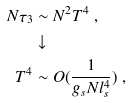Convert formula to latex. <formula><loc_0><loc_0><loc_500><loc_500>N \tau _ { 3 } & \sim N ^ { 2 } T ^ { 4 } \ , \\ & \downarrow \\ T ^ { 4 } & \sim O ( \frac { 1 } { g _ { s } N l _ { s } ^ { 4 } } ) \ ,</formula> 